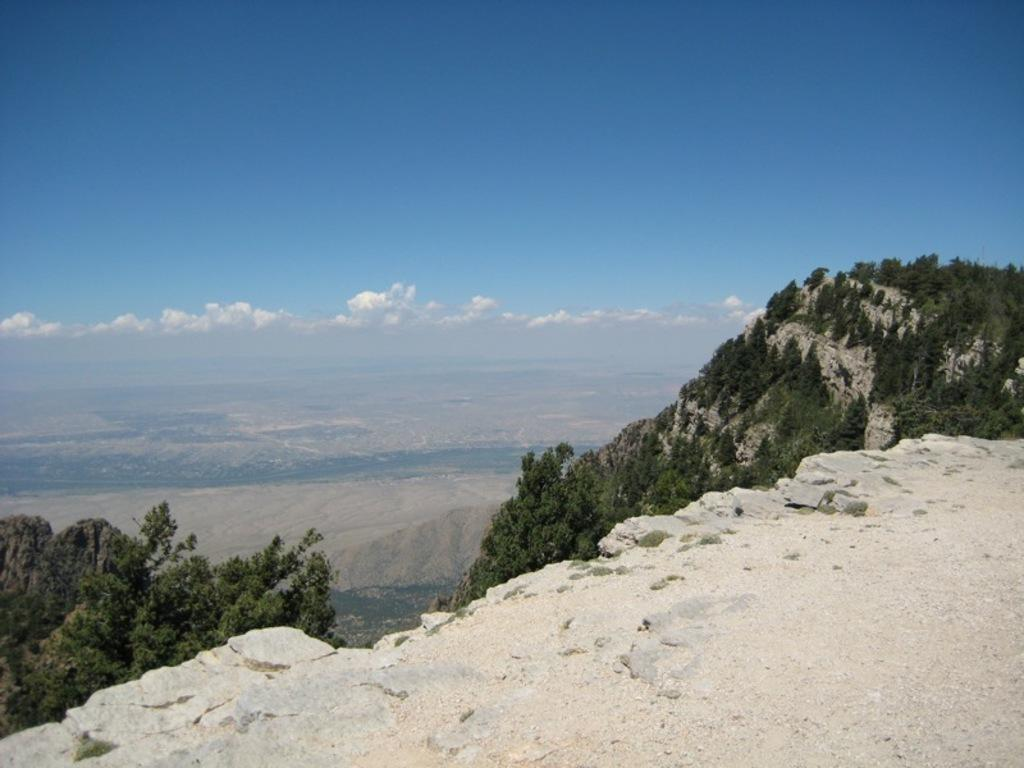What is the main geographical feature in the image? There is a mountain in the image. What can be seen on the mountain? There are trees on the mountain. Can you describe the background of the image? There might be additional mountains in the background. What is visible at the top of the image? The sky is visible at the top of the image. What can be seen in the sky? There are clouds in the sky. What is the title of the book that the person is reading on the mountain? There is no person or book present in the image; it features a mountain with trees and a sky with clouds. 